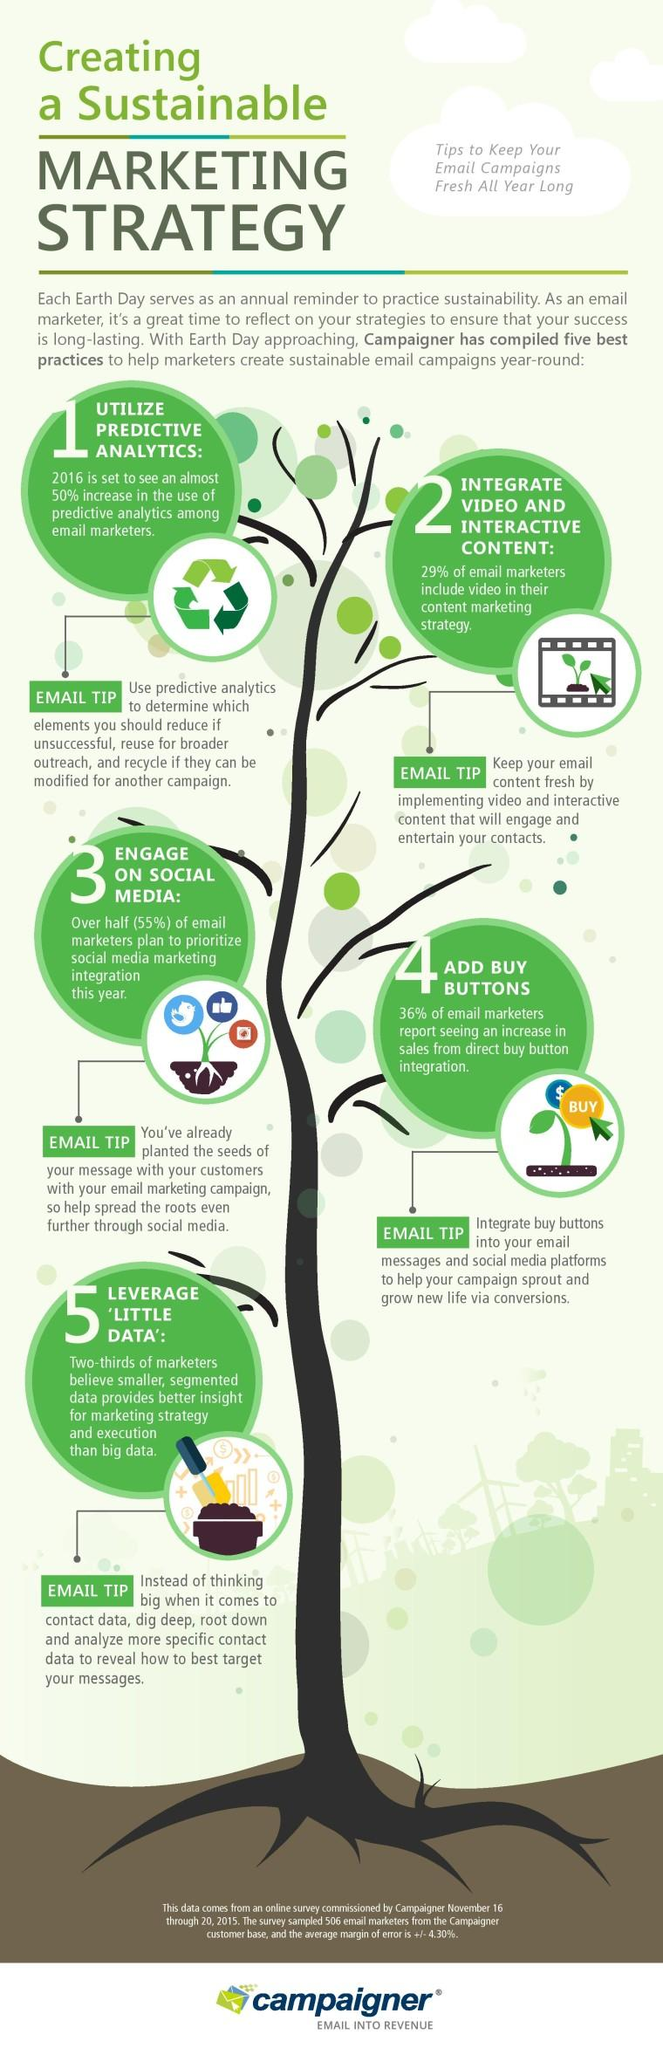Give some essential details in this illustration. It is certain that buying buttons are the most effective strategy for increasing sales, as they allow for immediate purchases and provide a clear call to action for customers. Predictive analysis and video and interactive content may also be useful in certain situations, but they do not guarantee increased sales in the same way that buying buttons do. Therefore, it can be concluded that buying buttons are the most reliable strategy for boosting sales. 